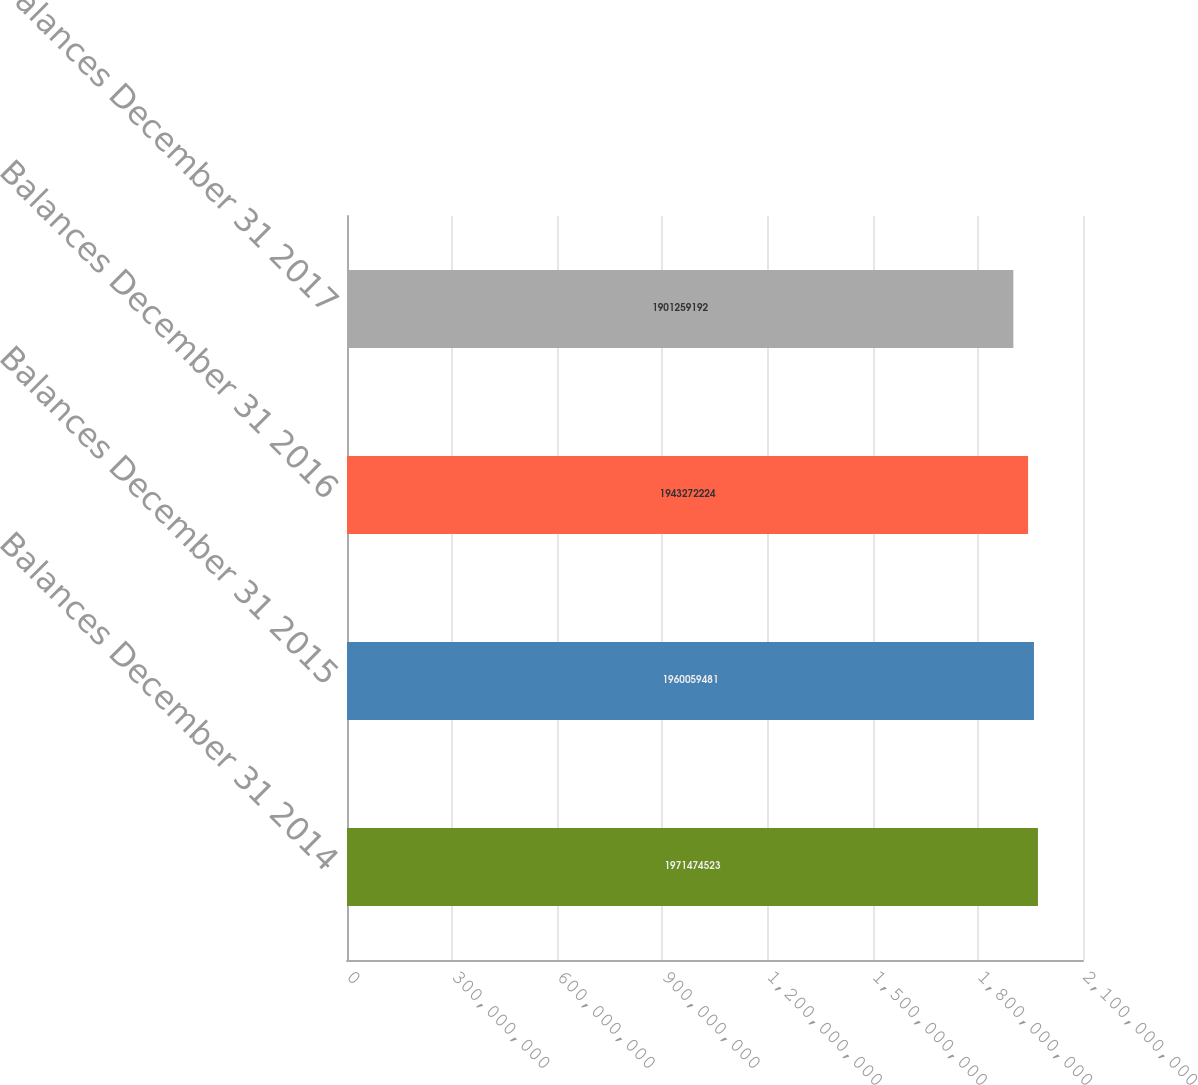<chart> <loc_0><loc_0><loc_500><loc_500><bar_chart><fcel>Balances December 31 2014<fcel>Balances December 31 2015<fcel>Balances December 31 2016<fcel>Balances December 31 2017<nl><fcel>1.97147e+09<fcel>1.96006e+09<fcel>1.94327e+09<fcel>1.90126e+09<nl></chart> 